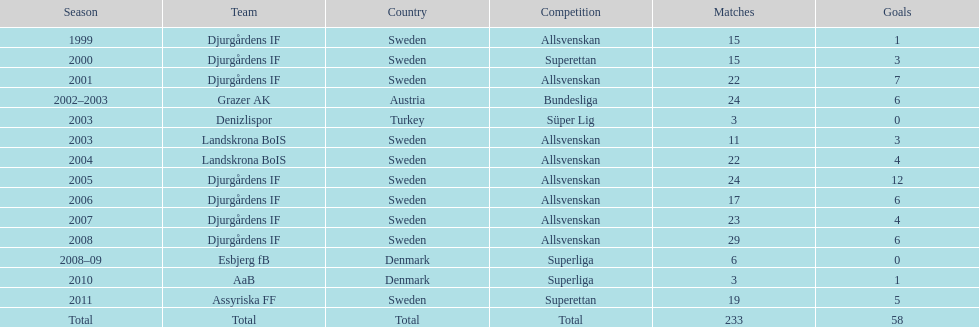How many matches did jones kusi-asare play in in his first season? 15. 